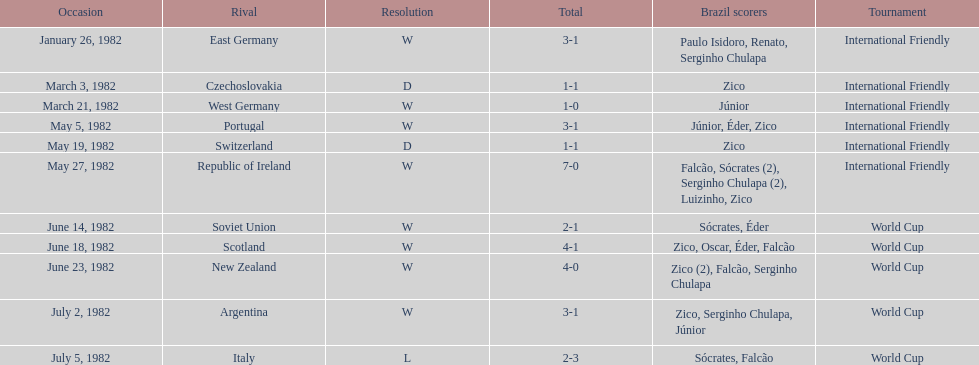Who won on january 26, 1982 and may 27, 1982? Brazil. 